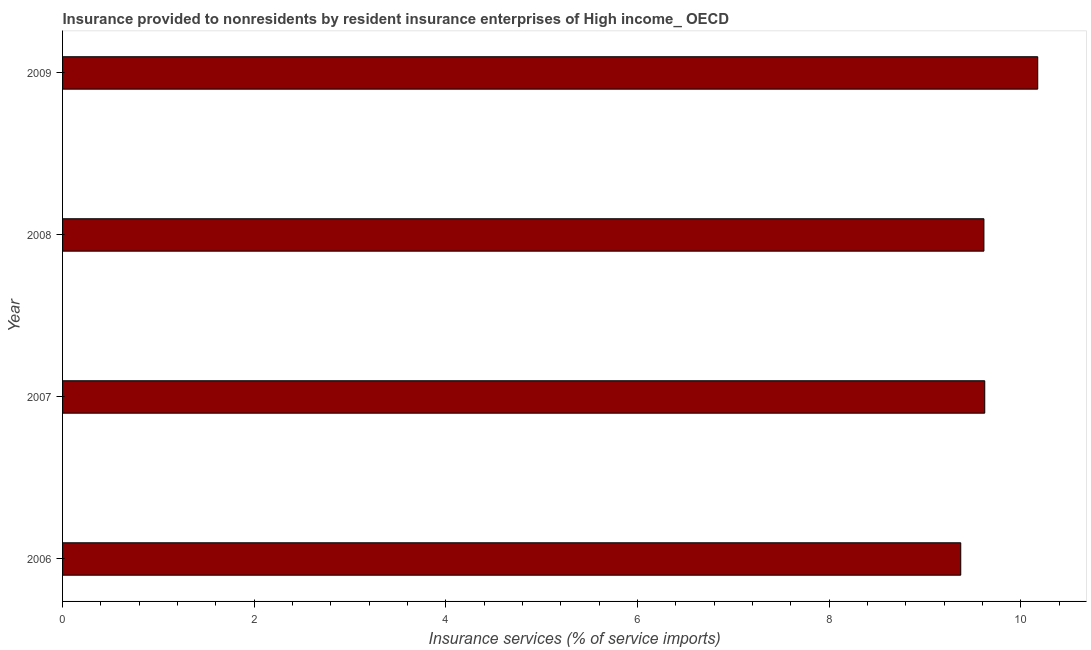Does the graph contain any zero values?
Give a very brief answer. No. Does the graph contain grids?
Provide a succinct answer. No. What is the title of the graph?
Your response must be concise. Insurance provided to nonresidents by resident insurance enterprises of High income_ OECD. What is the label or title of the X-axis?
Offer a very short reply. Insurance services (% of service imports). What is the insurance and financial services in 2006?
Your response must be concise. 9.37. Across all years, what is the maximum insurance and financial services?
Your response must be concise. 10.17. Across all years, what is the minimum insurance and financial services?
Offer a very short reply. 9.37. In which year was the insurance and financial services minimum?
Your answer should be very brief. 2006. What is the sum of the insurance and financial services?
Your response must be concise. 38.78. What is the difference between the insurance and financial services in 2008 and 2009?
Ensure brevity in your answer.  -0.56. What is the average insurance and financial services per year?
Give a very brief answer. 9.7. What is the median insurance and financial services?
Provide a succinct answer. 9.62. In how many years, is the insurance and financial services greater than 6 %?
Keep it short and to the point. 4. Do a majority of the years between 2008 and 2009 (inclusive) have insurance and financial services greater than 2.8 %?
Your response must be concise. Yes. What is the ratio of the insurance and financial services in 2008 to that in 2009?
Your answer should be compact. 0.94. Is the insurance and financial services in 2006 less than that in 2007?
Offer a terse response. Yes. Is the difference between the insurance and financial services in 2007 and 2009 greater than the difference between any two years?
Keep it short and to the point. No. What is the difference between the highest and the second highest insurance and financial services?
Give a very brief answer. 0.55. Is the sum of the insurance and financial services in 2006 and 2008 greater than the maximum insurance and financial services across all years?
Give a very brief answer. Yes. How many bars are there?
Ensure brevity in your answer.  4. Are all the bars in the graph horizontal?
Your response must be concise. Yes. How many years are there in the graph?
Make the answer very short. 4. What is the Insurance services (% of service imports) in 2006?
Keep it short and to the point. 9.37. What is the Insurance services (% of service imports) of 2007?
Provide a succinct answer. 9.62. What is the Insurance services (% of service imports) of 2008?
Ensure brevity in your answer.  9.61. What is the Insurance services (% of service imports) of 2009?
Offer a very short reply. 10.17. What is the difference between the Insurance services (% of service imports) in 2006 and 2007?
Offer a terse response. -0.25. What is the difference between the Insurance services (% of service imports) in 2006 and 2008?
Provide a succinct answer. -0.24. What is the difference between the Insurance services (% of service imports) in 2006 and 2009?
Your response must be concise. -0.8. What is the difference between the Insurance services (% of service imports) in 2007 and 2008?
Your answer should be compact. 0.01. What is the difference between the Insurance services (% of service imports) in 2007 and 2009?
Make the answer very short. -0.55. What is the difference between the Insurance services (% of service imports) in 2008 and 2009?
Give a very brief answer. -0.56. What is the ratio of the Insurance services (% of service imports) in 2006 to that in 2007?
Your answer should be compact. 0.97. What is the ratio of the Insurance services (% of service imports) in 2006 to that in 2008?
Keep it short and to the point. 0.97. What is the ratio of the Insurance services (% of service imports) in 2006 to that in 2009?
Make the answer very short. 0.92. What is the ratio of the Insurance services (% of service imports) in 2007 to that in 2009?
Offer a terse response. 0.95. What is the ratio of the Insurance services (% of service imports) in 2008 to that in 2009?
Keep it short and to the point. 0.94. 